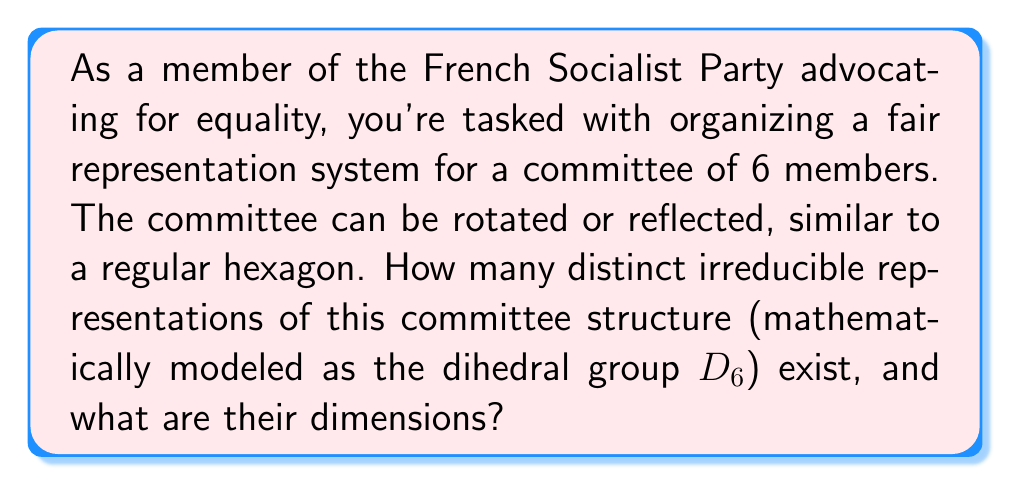Can you solve this math problem? Let's approach this step-by-step:

1) The dihedral group D6 has order 12 and is generated by two elements: a rotation r of order 6 and a reflection s of order 2.

2) To find the irreducible representations, we'll use the formula:
   $$\sum_{i=1}^k n_i^2 = |G| = 12$$
   where $n_i$ are the dimensions of the irreducible representations.

3) D6 has 6 conjugacy classes:
   {e}, {r³}, {r, r⁵}, {r², r⁴}, {s, sr², sr⁴}, {sr, sr³, sr⁵}

4) The number of irreducible representations equals the number of conjugacy classes, so k = 6.

5) We know that D6 has 4 one-dimensional representations:
   - The trivial representation
   - The sign representation
   - Two representations sending r to -1 and s to ±1

6) The remaining two representations must be two-dimensional to satisfy the equation:
   $$1^2 + 1^2 + 1^2 + 1^2 + 2^2 + 2^2 = 12$$

7) These two-dimensional representations can be constructed as:
   $$r \mapsto \begin{pmatrix} \cos(2\pi/6) & -\sin(2\pi/6) \\ \sin(2\pi/6) & \cos(2\pi/6) \end{pmatrix}, 
     s \mapsto \begin{pmatrix} 1 & 0 \\ 0 & -1 \end{pmatrix}$$
   $$r \mapsto \begin{pmatrix} \cos(4\pi/6) & -\sin(4\pi/6) \\ \sin(4\pi/6) & \cos(4\pi/6) \end{pmatrix}, 
     s \mapsto \begin{pmatrix} 1 & 0 \\ 0 & -1 \end{pmatrix}$$

Therefore, D6 has 6 irreducible representations: four of dimension 1 and two of dimension 2.
Answer: 6 irreducible representations: 4 of dimension 1, 2 of dimension 2 